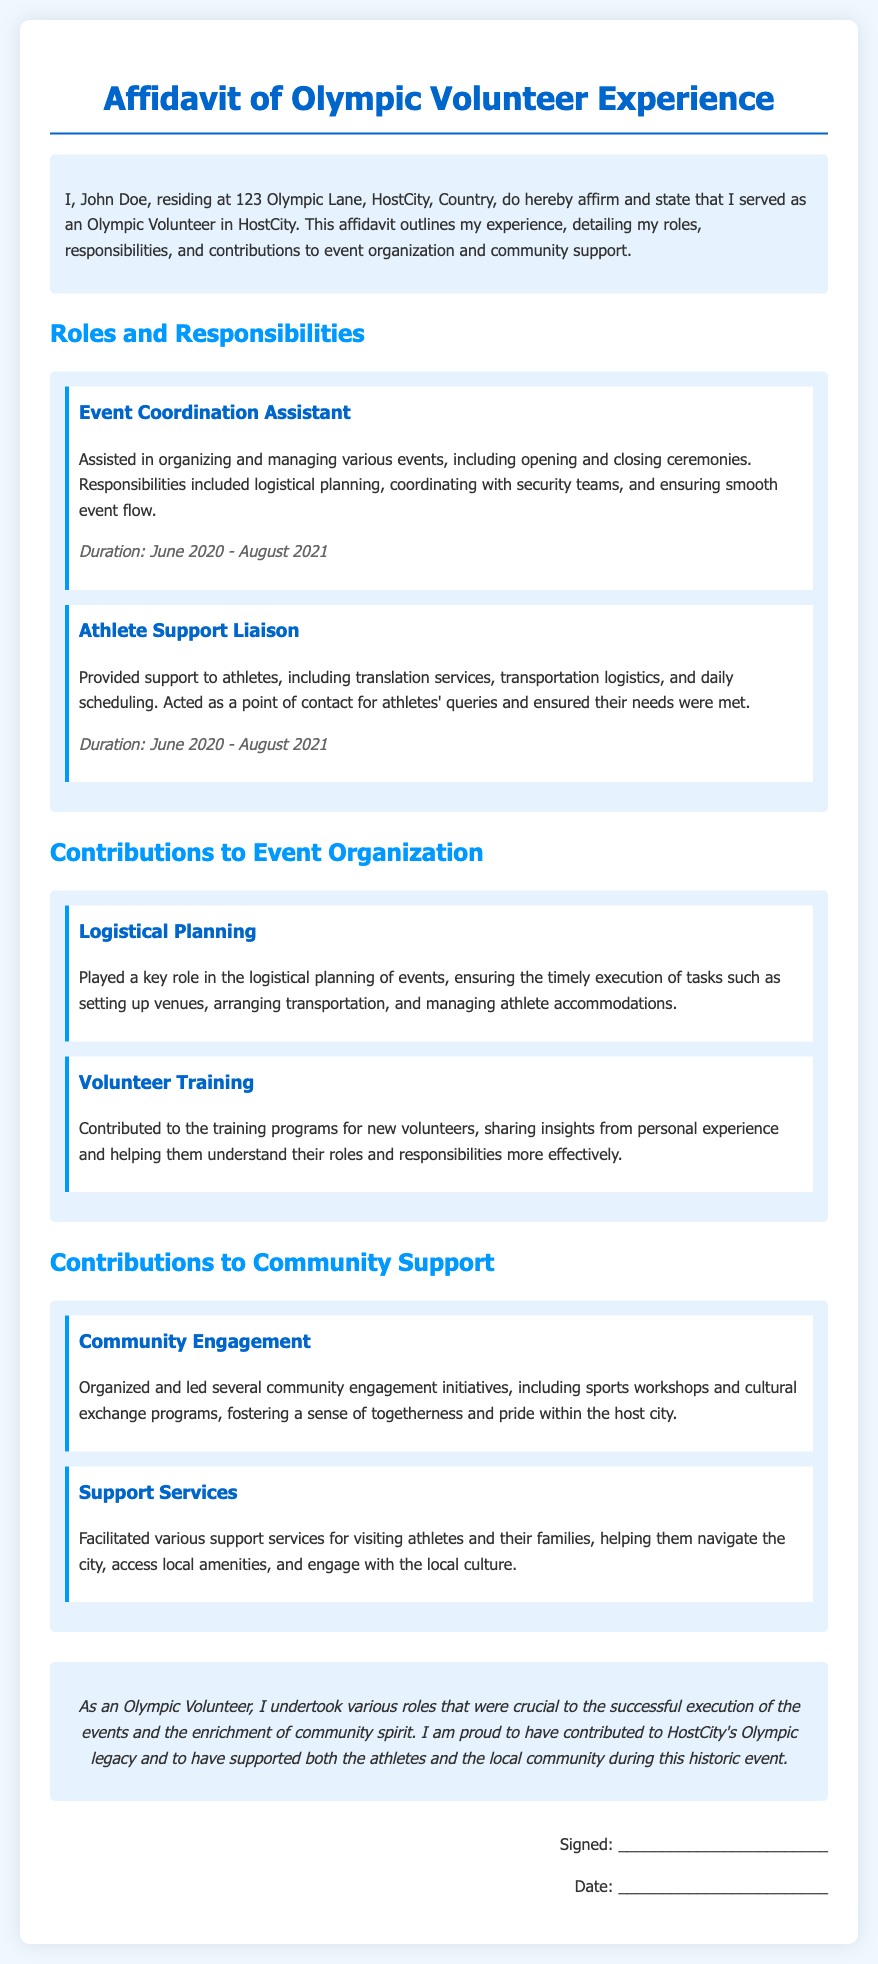What is the name of the individual giving the affidavit? The name of the individual is mentioned at the beginning of the document in the introductory statement.
Answer: John Doe What was the duration of the volunteer experience? The duration is stated in the roles and responsibilities section under each role.
Answer: June 2020 - August 2021 What role involved logistical planning for events? The role that specifically mentions logistical planning is stated as part of the roles and responsibilities.
Answer: Event Coordination Assistant What kind of support did the Athlete Support Liaison provide? This role describes the type of support given to athletes in the responsibilities mentioned.
Answer: Transportation logistics Which community engagement initiatives were organized? The specific initiatives are listed under contributions to community support.
Answer: Sports workshops and cultural exchange programs What is John Doe's address? The address is provided in the introductory statement of the document.
Answer: 123 Olympic Lane, HostCity, Country What was one key contribution to event organization? The contributions to event organization are highlighted within their specific section in the affidavit.
Answer: Logistical Planning What role involved training new volunteers? The contribution mentions training programs that John Doe was involved in.
Answer: Volunteer Training How is the conclusion of the affidavit summarized? The conclusion summarizes the overall impact of John Doe’s volunteer experience and contributions.
Answer: Olympic legacy 